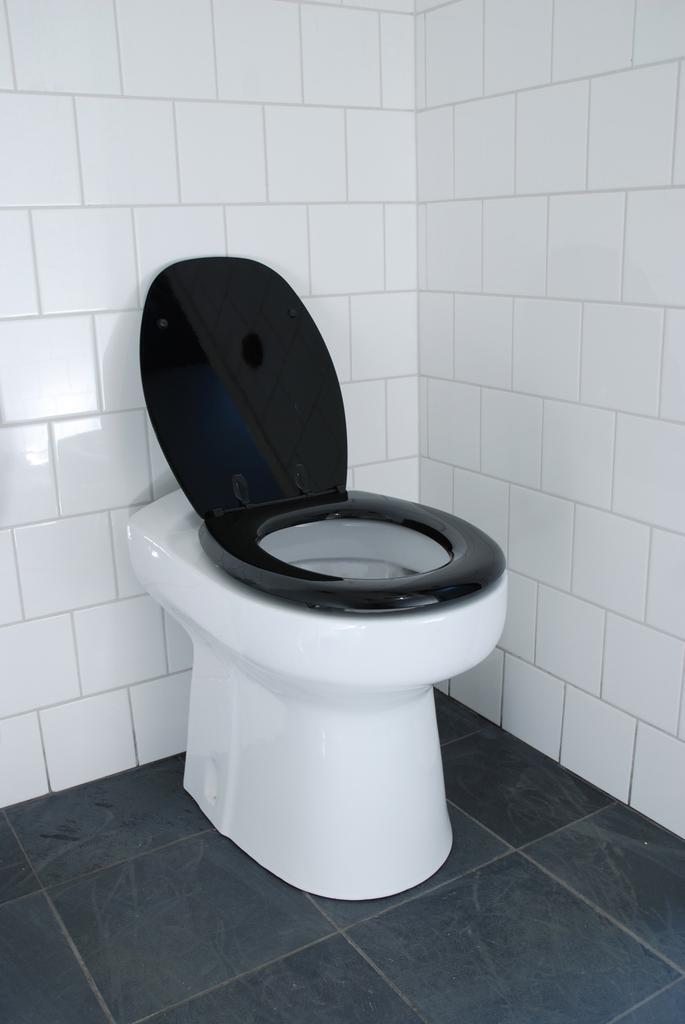Describe this image in one or two sentences. In the center of the picture there is a toilet basin. At the bottom it is floor. In the center of the picture it is well. 